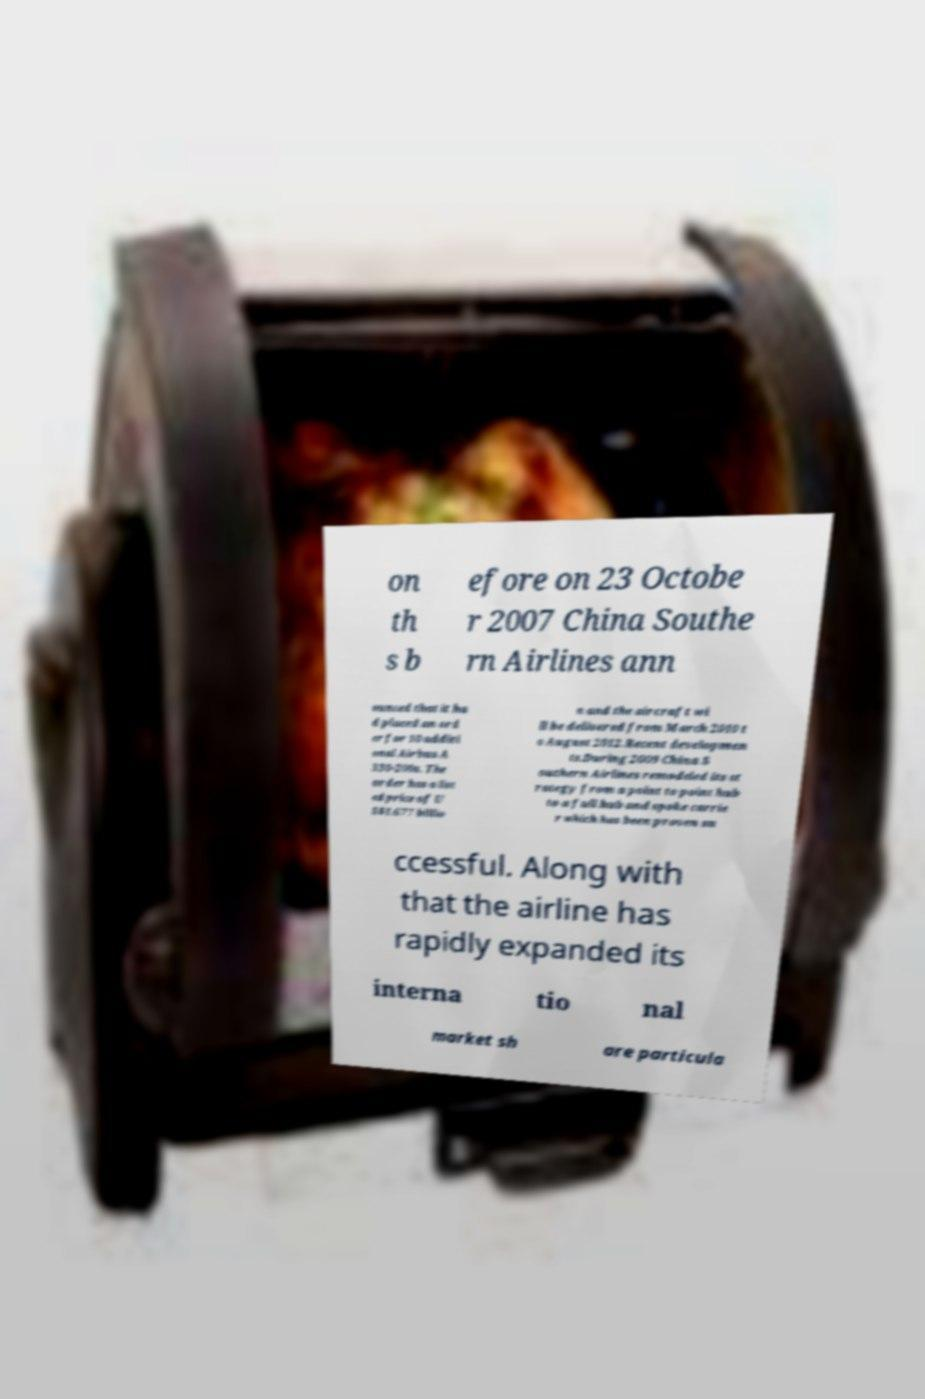Please identify and transcribe the text found in this image. on th s b efore on 23 Octobe r 2007 China Southe rn Airlines ann ounced that it ha d placed an ord er for 10 additi onal Airbus A 330-200s. The order has a list ed price of U S$1.677 billio n and the aircraft wi ll be delivered from March 2010 t o August 2012.Recent developmen ts.During 2009 China S outhern Airlines remodeled its st rategy from a point to point hub to a full hub and spoke carrie r which has been proven su ccessful. Along with that the airline has rapidly expanded its interna tio nal market sh are particula 